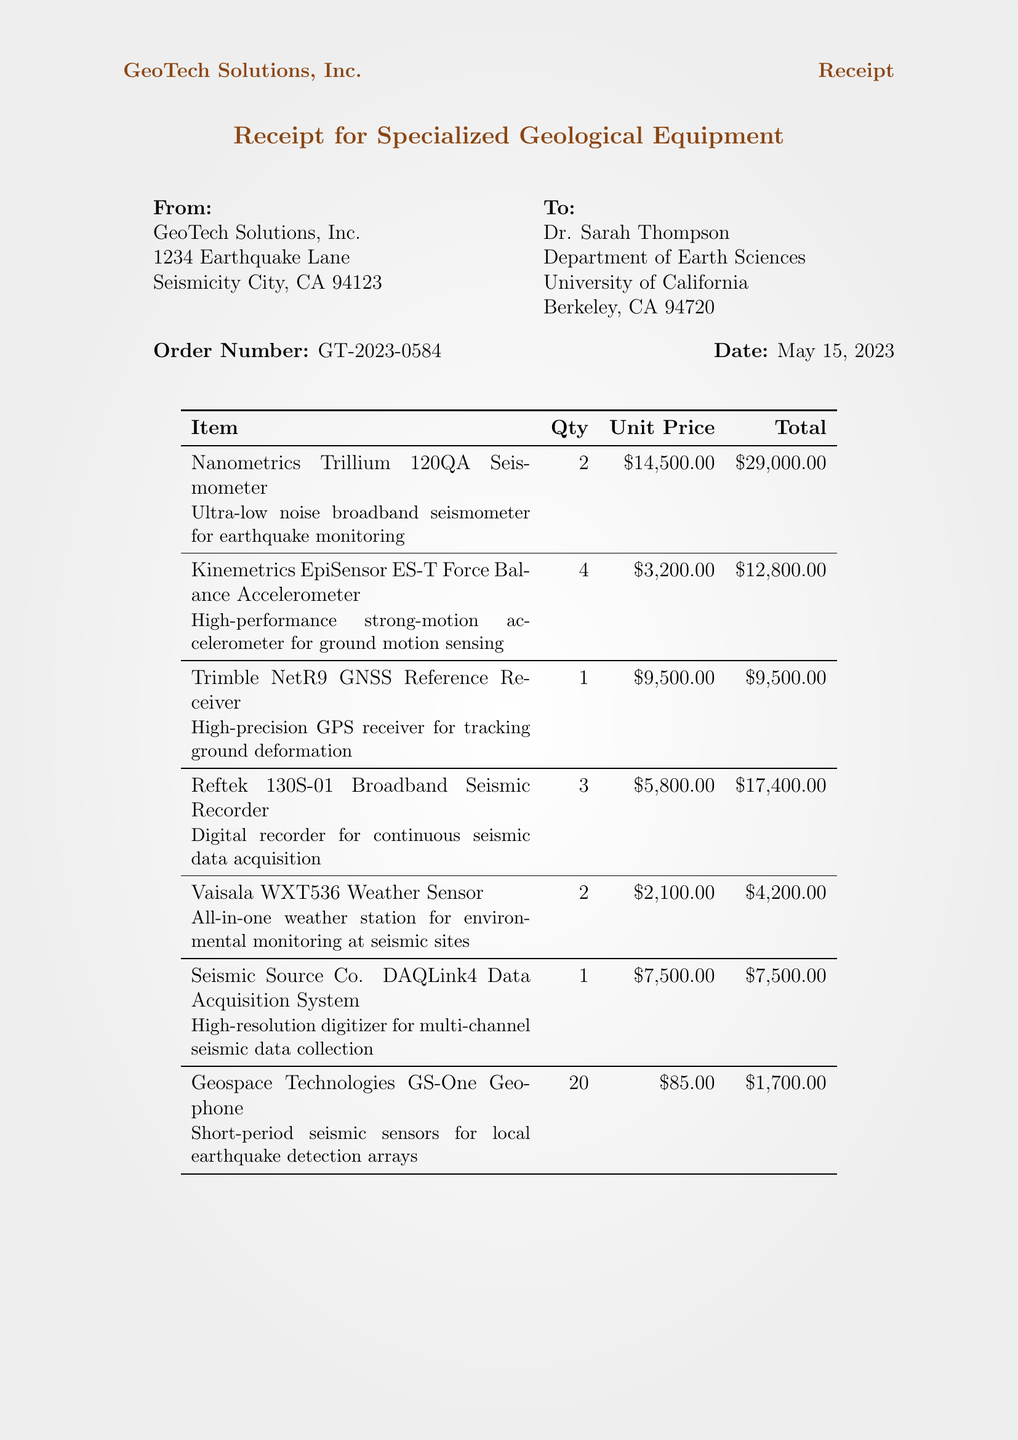What is the name of the company? The company issuing the receipt is GeoTech Solutions, Inc.
Answer: GeoTech Solutions, Inc Who is the customer? The customer's name is Dr. Sarah Thompson, as stated in the document.
Answer: Dr. Sarah Thompson What is the order number? The order number is provided for reference in the document as GT-2023-0584.
Answer: GT-2023-0584 How many Trimble NetR9 GNSS Reference Receivers were ordered? The quantity of Trimble NetR9 GNSS Reference Receivers is listed in the document as 1.
Answer: 1 What is the total amount due? The document specifies the total amount due as $91,194.25.
Answer: $91,194.25 What item is used for continuous seismic data acquisition? The item used for continuous seismic data acquisition is the Reftek 130S-01 Broadband Seismic Recorder.
Answer: Reftek 130S-01 Broadband Seismic Recorder How many Kinemetrics EpiSensor ES-T Accelerometers were purchased? The document states that 4 Kinemetrics EpiSensor ES-T Accelerometers were purchased.
Answer: 4 What is the shipping cost? The shipping cost incurred for this order is stated as $1,500.00.
Answer: $1,500.00 What is the purpose noted for the equipment? The purpose noted for the equipment is related to the California Seismic Network Expansion Project.
Answer: California Seismic Network Expansion Project 